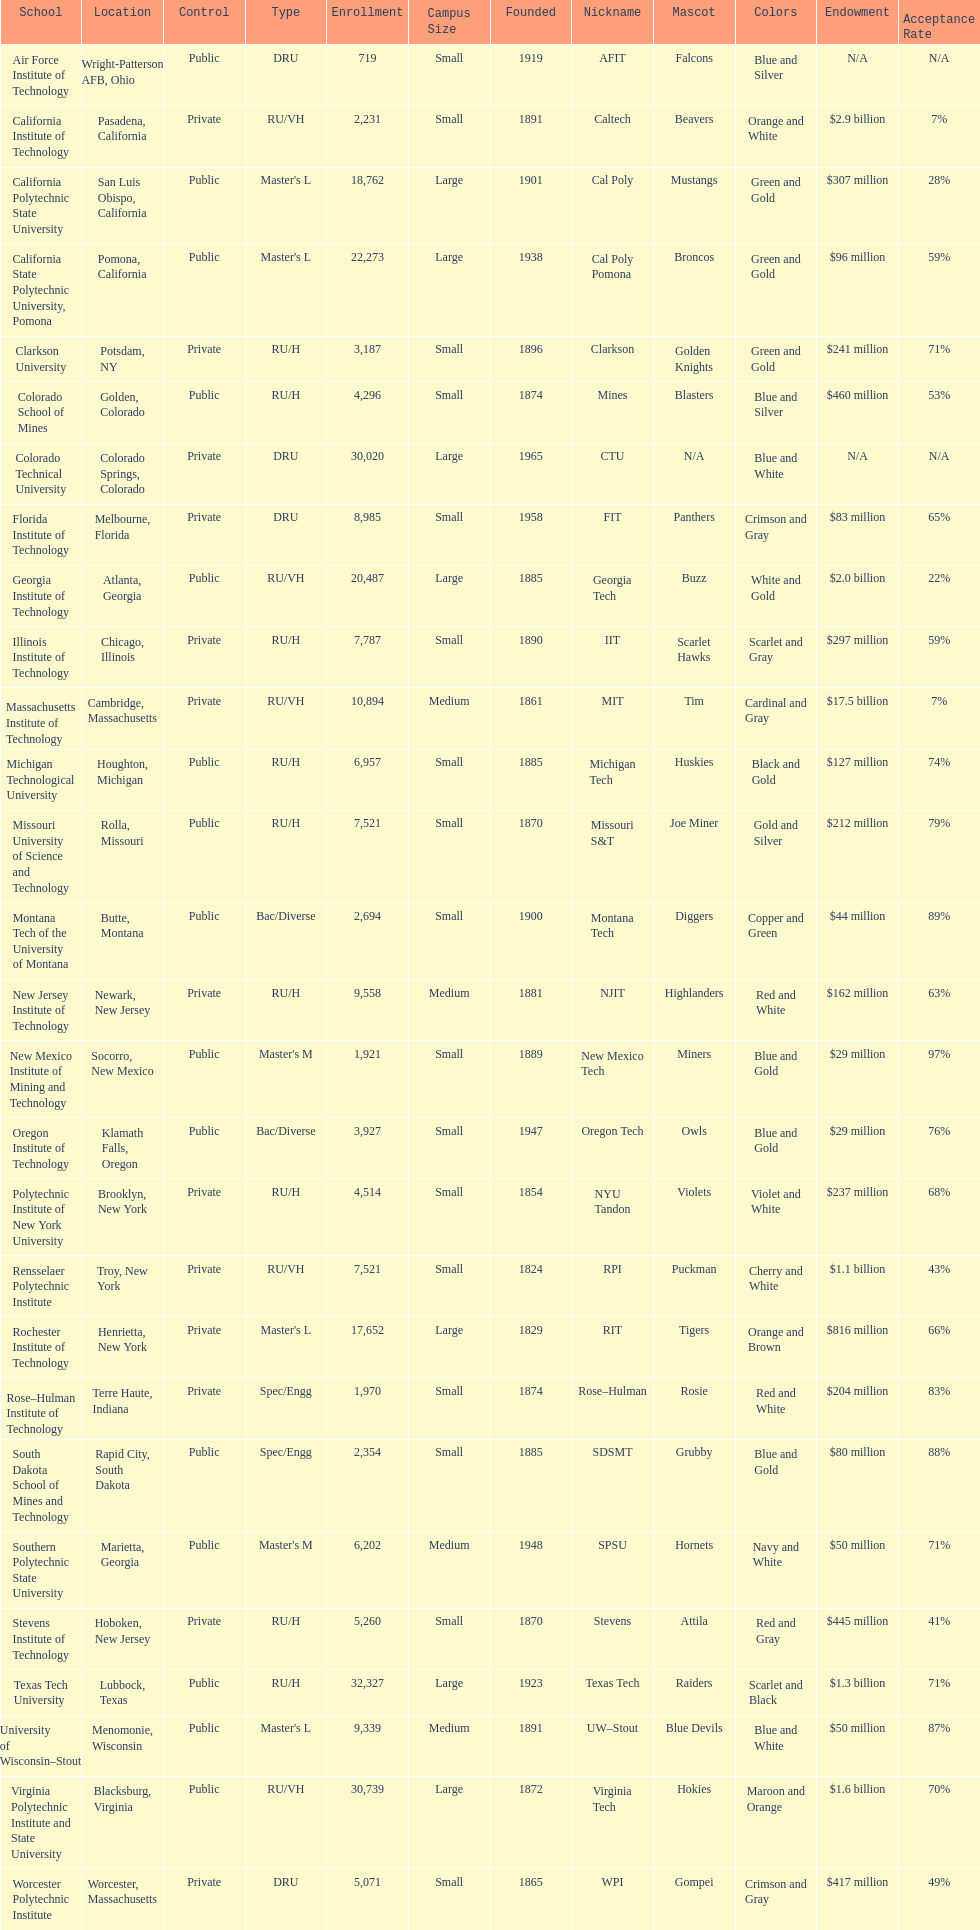How many of the universities were located in california? 3. 